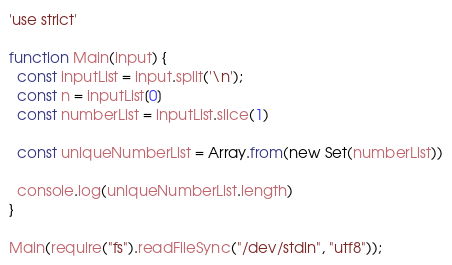Convert code to text. <code><loc_0><loc_0><loc_500><loc_500><_JavaScript_>'use strict'

function Main(input) {
  const inputList = input.split('\n');
  const n = inputList[0]
  const numberList = inputList.slice(1)

  const uniqueNumberList = Array.from(new Set(numberList))

  console.log(uniqueNumberList.length)
}

Main(require("fs").readFileSync("/dev/stdin", "utf8"));</code> 